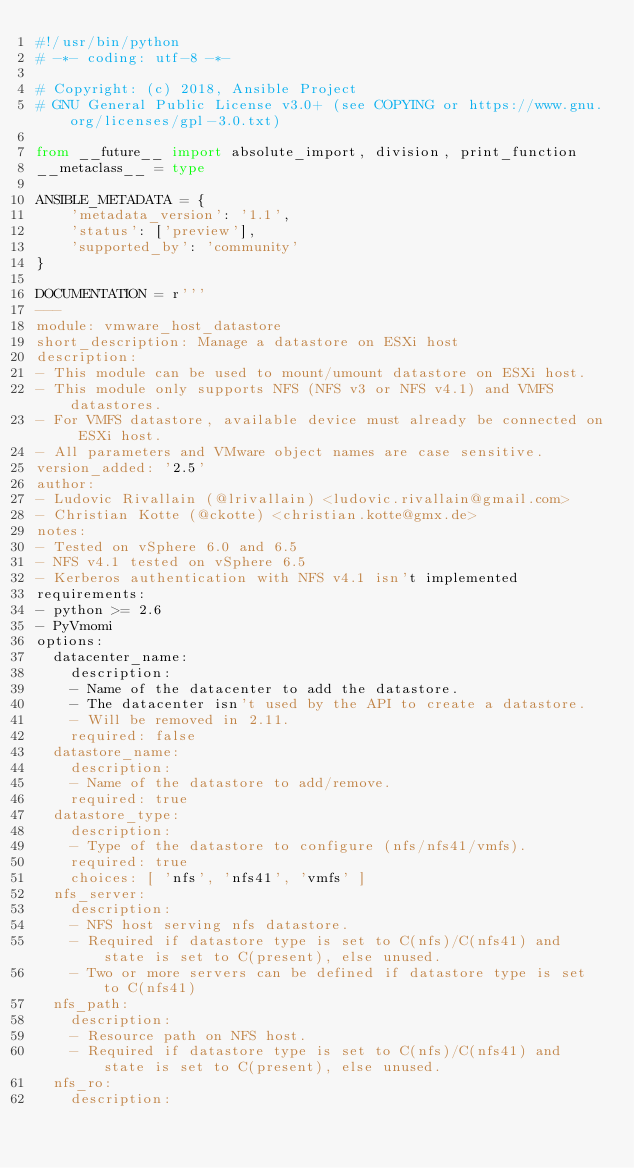<code> <loc_0><loc_0><loc_500><loc_500><_Python_>#!/usr/bin/python
# -*- coding: utf-8 -*-

# Copyright: (c) 2018, Ansible Project
# GNU General Public License v3.0+ (see COPYING or https://www.gnu.org/licenses/gpl-3.0.txt)

from __future__ import absolute_import, division, print_function
__metaclass__ = type

ANSIBLE_METADATA = {
    'metadata_version': '1.1',
    'status': ['preview'],
    'supported_by': 'community'
}

DOCUMENTATION = r'''
---
module: vmware_host_datastore
short_description: Manage a datastore on ESXi host
description:
- This module can be used to mount/umount datastore on ESXi host.
- This module only supports NFS (NFS v3 or NFS v4.1) and VMFS datastores.
- For VMFS datastore, available device must already be connected on ESXi host.
- All parameters and VMware object names are case sensitive.
version_added: '2.5'
author:
- Ludovic Rivallain (@lrivallain) <ludovic.rivallain@gmail.com>
- Christian Kotte (@ckotte) <christian.kotte@gmx.de>
notes:
- Tested on vSphere 6.0 and 6.5
- NFS v4.1 tested on vSphere 6.5
- Kerberos authentication with NFS v4.1 isn't implemented
requirements:
- python >= 2.6
- PyVmomi
options:
  datacenter_name:
    description:
    - Name of the datacenter to add the datastore.
    - The datacenter isn't used by the API to create a datastore.
    - Will be removed in 2.11.
    required: false
  datastore_name:
    description:
    - Name of the datastore to add/remove.
    required: true
  datastore_type:
    description:
    - Type of the datastore to configure (nfs/nfs41/vmfs).
    required: true
    choices: [ 'nfs', 'nfs41', 'vmfs' ]
  nfs_server:
    description:
    - NFS host serving nfs datastore.
    - Required if datastore type is set to C(nfs)/C(nfs41) and state is set to C(present), else unused.
    - Two or more servers can be defined if datastore type is set to C(nfs41)
  nfs_path:
    description:
    - Resource path on NFS host.
    - Required if datastore type is set to C(nfs)/C(nfs41) and state is set to C(present), else unused.
  nfs_ro:
    description:</code> 